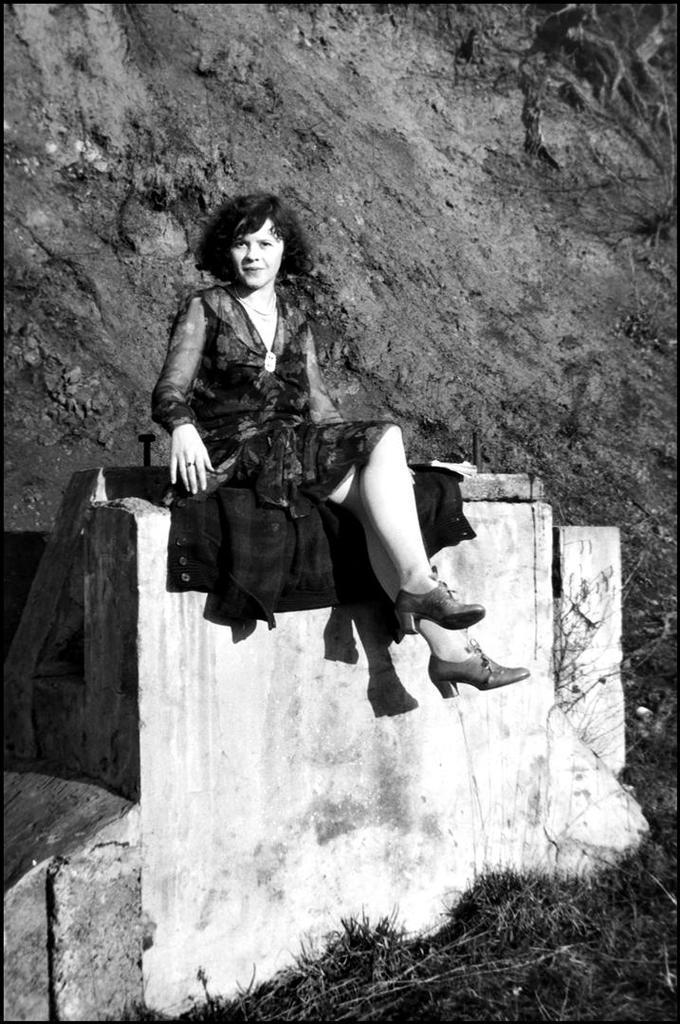Describe this image in one or two sentences. This is a black and white image. In this image we can see a woman sitting on the wall. In the background there is a rock. 